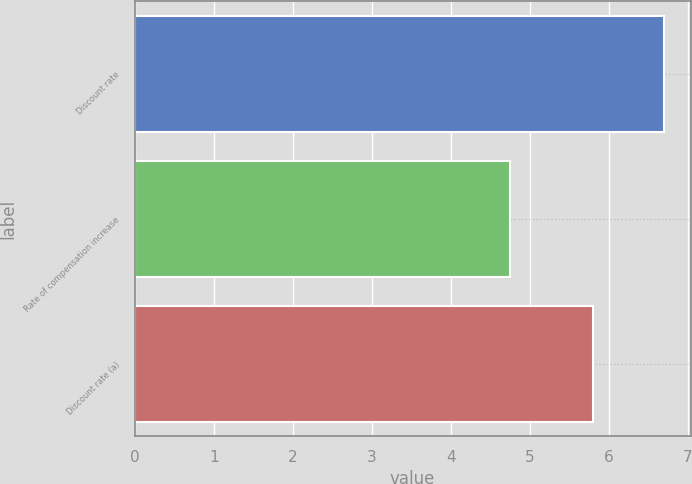Convert chart. <chart><loc_0><loc_0><loc_500><loc_500><bar_chart><fcel>Discount rate<fcel>Rate of compensation increase<fcel>Discount rate (a)<nl><fcel>6.7<fcel>4.75<fcel>5.8<nl></chart> 